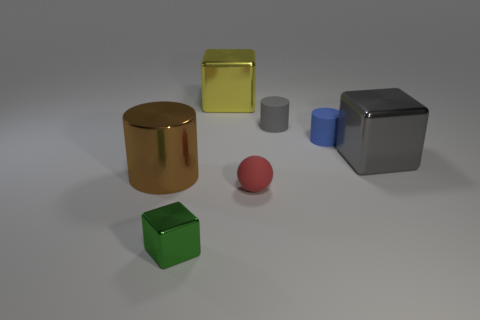How many objects are big cyan metal blocks or tiny rubber cylinders?
Offer a terse response. 2. What size is the yellow metal block behind the gray matte cylinder that is behind the object left of the green object?
Give a very brief answer. Large. How many other matte balls are the same color as the sphere?
Make the answer very short. 0. How many other things are the same material as the red object?
Provide a short and direct response. 2. How many things are large yellow things or matte balls that are left of the gray matte thing?
Keep it short and to the point. 2. The large metal object on the left side of the green metallic block that is right of the big object left of the green cube is what color?
Provide a succinct answer. Brown. What size is the block that is in front of the brown object?
Keep it short and to the point. Small. What number of tiny objects are blue matte objects or yellow shiny objects?
Your response must be concise. 1. The cube that is left of the small rubber sphere and behind the matte sphere is what color?
Your answer should be very brief. Yellow. Is there another green thing that has the same shape as the small shiny object?
Your response must be concise. No. 